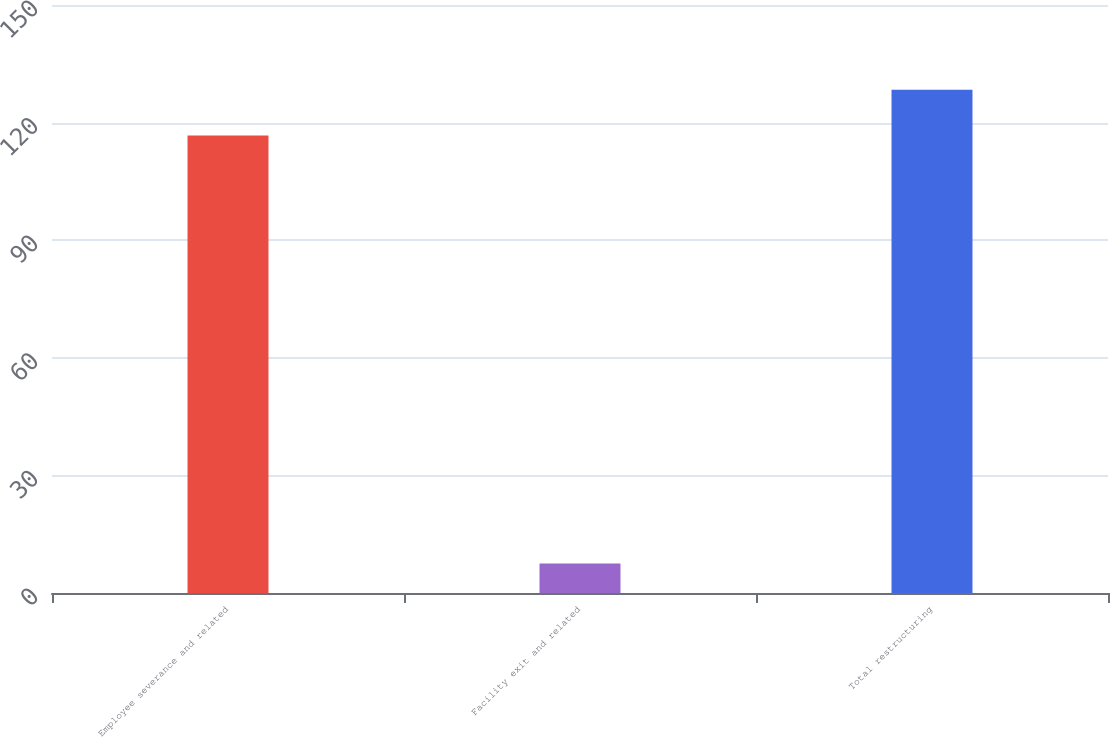<chart> <loc_0><loc_0><loc_500><loc_500><bar_chart><fcel>Employee severance and related<fcel>Facility exit and related<fcel>Total restructuring<nl><fcel>116.7<fcel>7.5<fcel>128.37<nl></chart> 